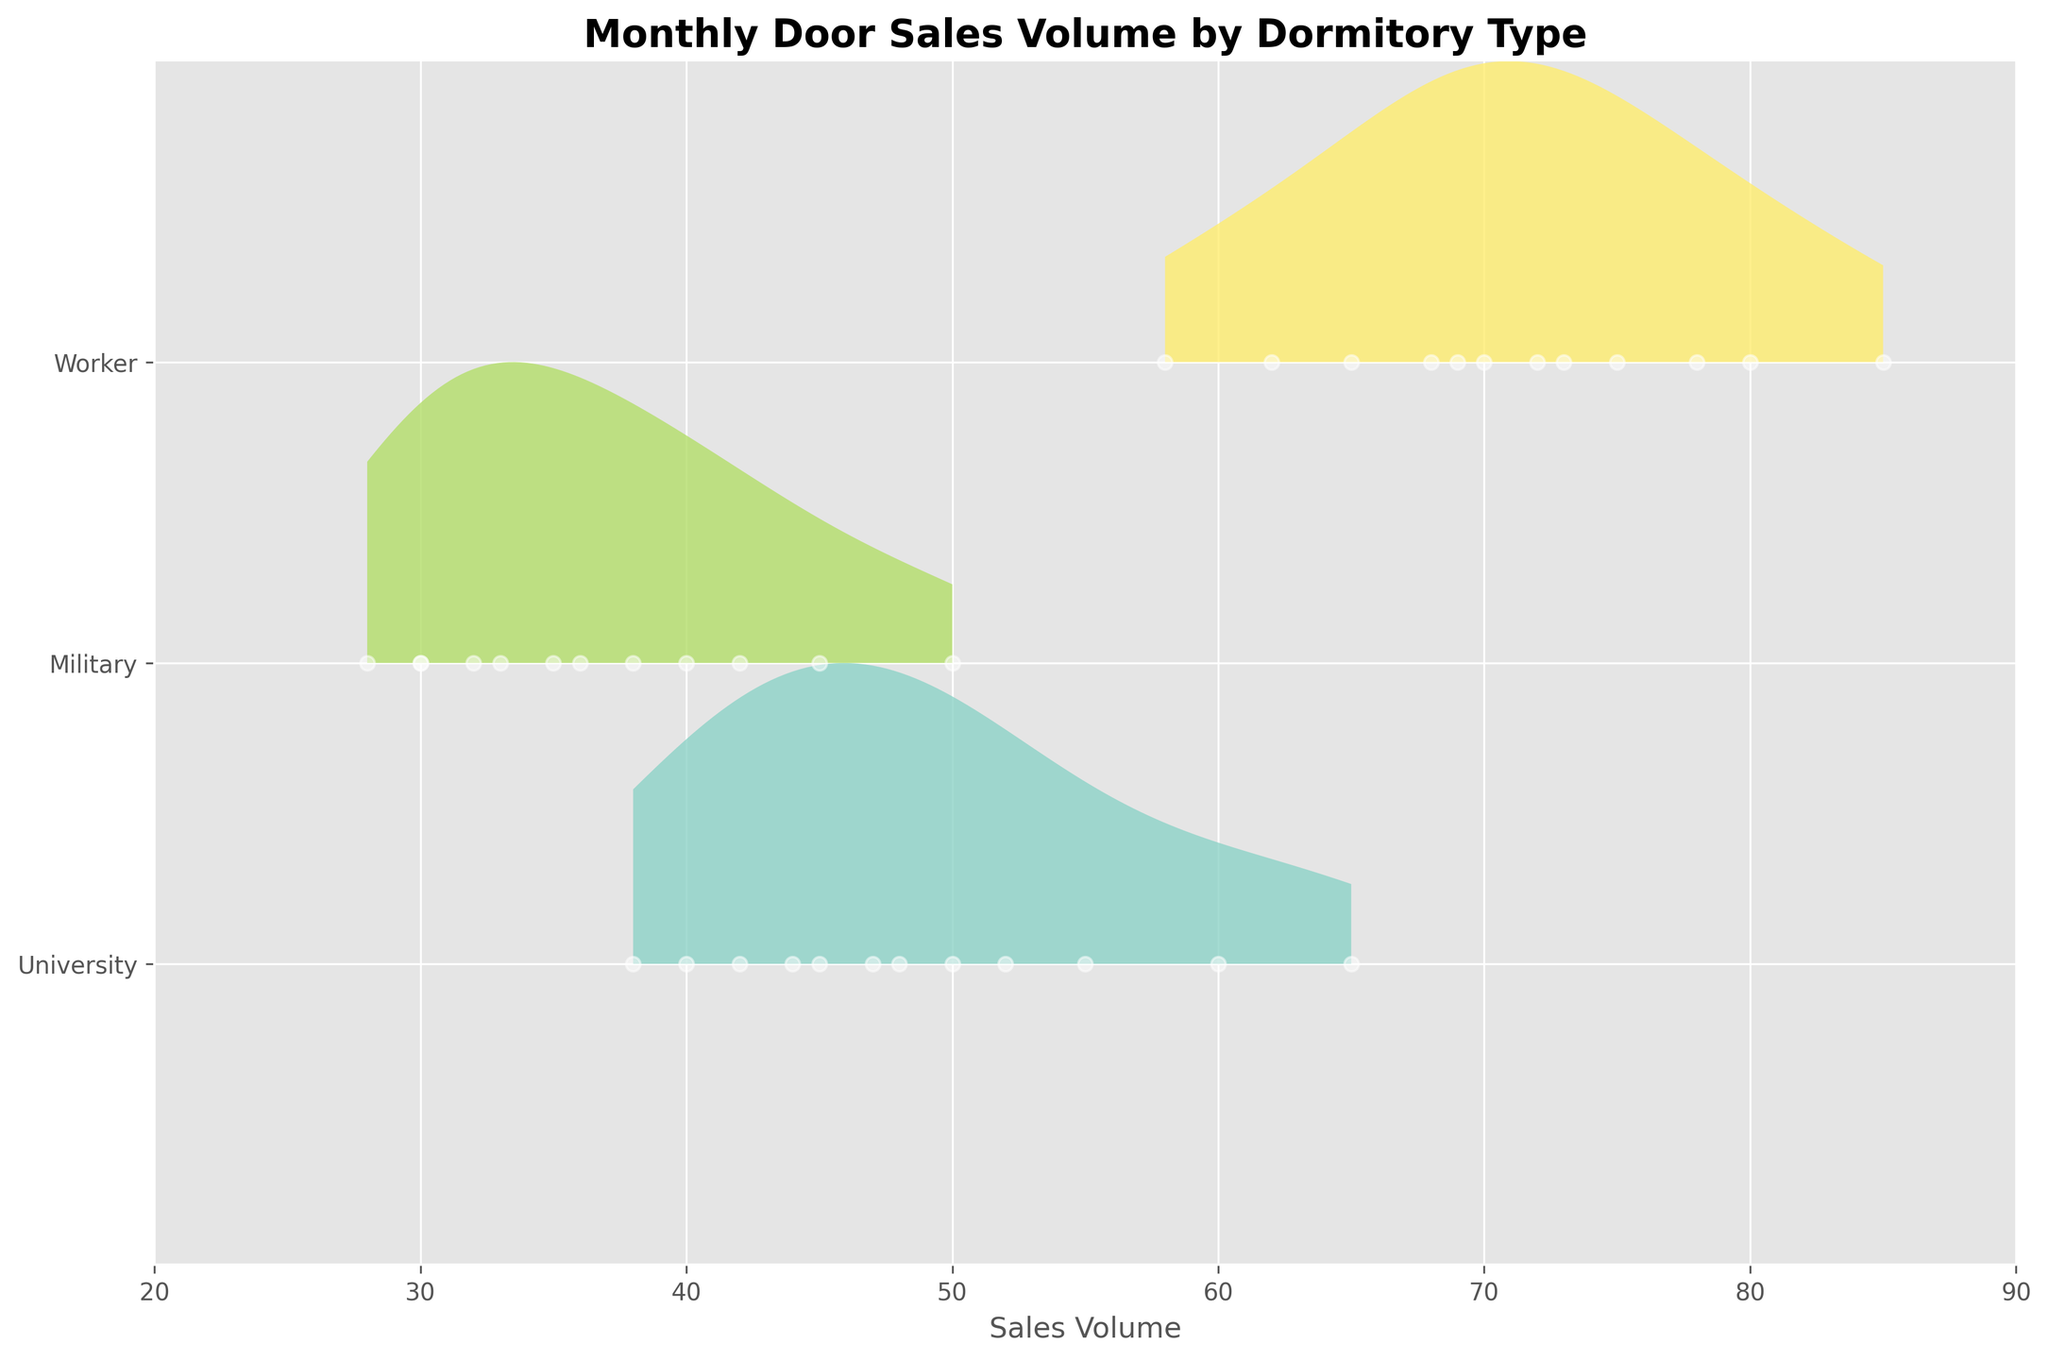What is the title of the plot? The title is usually found at the top of the plot. In this case, reading the top of the plot shows the title "Monthly Door Sales Volume by Dormitory Type."
Answer: Monthly Door Sales Volume by Dormitory Type What type of dormitory had the highest sales volume in August? For August, we need to look at the section of the plot related to August and identify the dormitory type with the highest sales peak. The plot shows that the Worker dormitory type has the highest peak in August.
Answer: Worker Which month did the Military dormitory type have its highest sales volume, and what was that volume? We look through the plot for the Military dormitory type and find the month where its curve reaches the highest point. This occurred in August with a sales volume of 50.
Answer: August, 50 How many sales points are plotted for each type throughout the year? By examining the plot, we see that each month has one point for each dormitory type, and since there are 12 months, there are 12 points for each dormitory type.
Answer: 12 Which dormitory type saw an increase in sales from July to August? We compare the positions of the points for July and August for each dormitory type. The Worker and University dormitory types show an increase in sales from July to August.
Answer: Worker and University What is the average sales volume for the University dormitory type over the year? Add up the sales volumes for the University dormitory type for each month and then divide by 12 to find the average. (42 + 38 + 45 + 50 + 55 + 48 + 40 + 60 + 65 + 52 + 47 + 44) / 12 = 48.833
Answer: 48.833 Which dormitory type had the most fluctuating sales volumes throughout the year, and what indicates this? Fluctuations can be identified by observing the variability in the peak positions along the months for each type. The Worker dormitory type shows significant fluctuations with high variability in peak positions.
Answer: Worker Compare the sales volumes of the Worker and Military dormitory types in January. Which one was higher and by how much? Look at the sales volume points for both Worker and Military in January; Worker had 65 and Military had 28. The difference is 65 - 28 = 37.
Answer: Worker by 37 